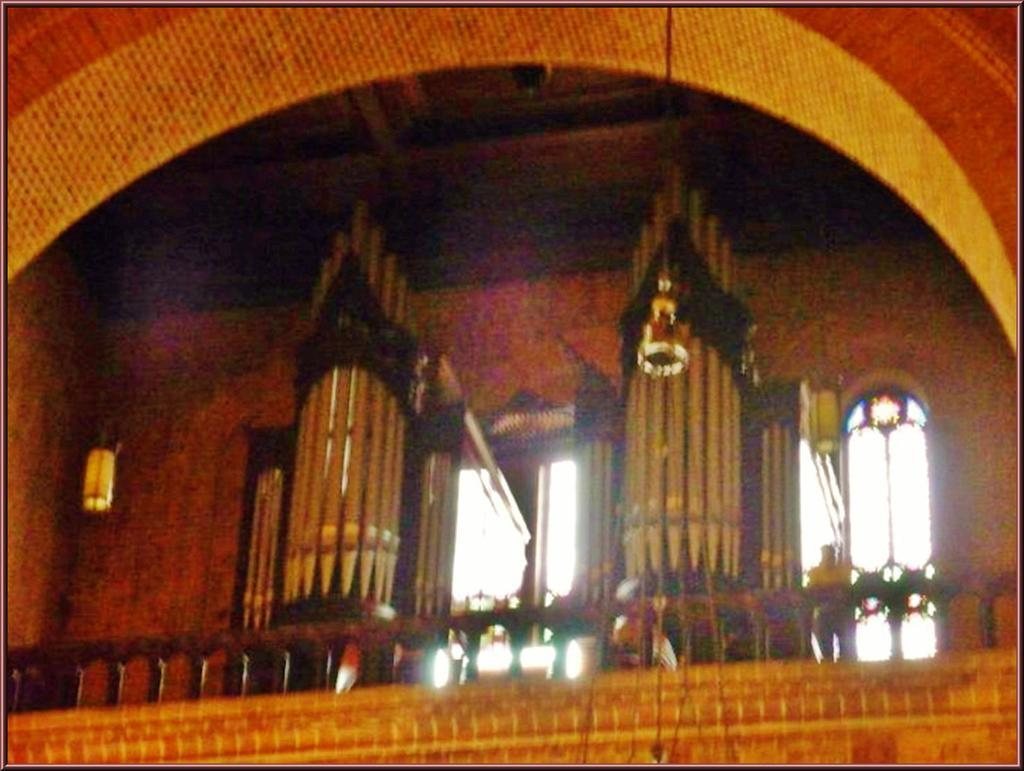What type of view is shown in the image? The image shows an interior view of a building. What structural elements can be seen in the image? There are walls visible in the image, as well as railing. How many doors are present in the image? There are two doors in the image. Is there any decoration near the doors? Yes, there is some decoration near the doors. What type of cap is the manager wearing in the image? There is no manager or cap present in the image. How many attempts does the person in the image make to open the door? There is no person attempting to open a door in the image. 